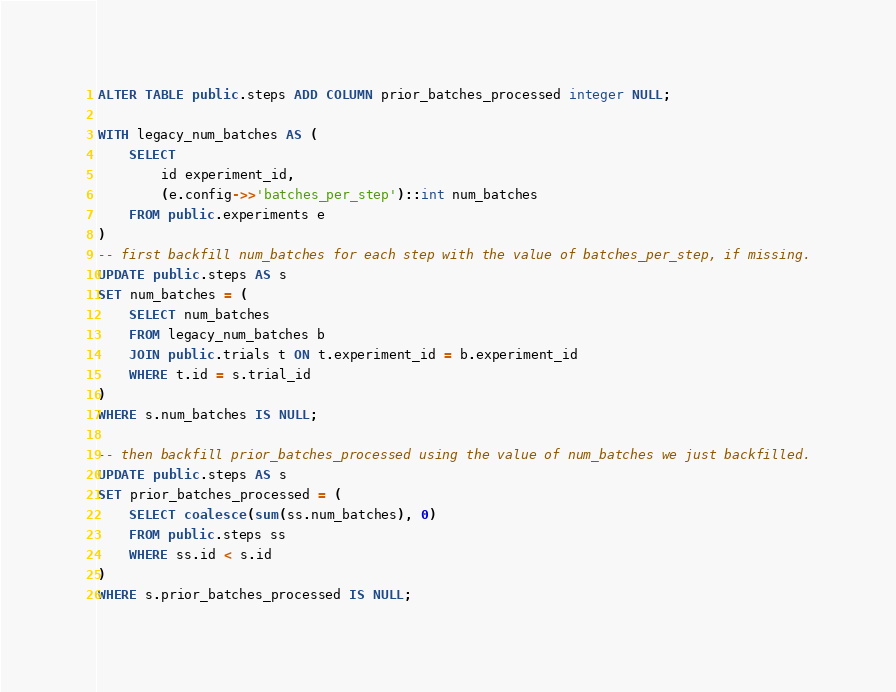Convert code to text. <code><loc_0><loc_0><loc_500><loc_500><_SQL_>ALTER TABLE public.steps ADD COLUMN prior_batches_processed integer NULL;

WITH legacy_num_batches AS (
    SELECT
        id experiment_id,
        (e.config->>'batches_per_step')::int num_batches
    FROM public.experiments e
)
-- first backfill num_batches for each step with the value of batches_per_step, if missing.
UPDATE public.steps AS s
SET num_batches = (
    SELECT num_batches
    FROM legacy_num_batches b
    JOIN public.trials t ON t.experiment_id = b.experiment_id
    WHERE t.id = s.trial_id
)
WHERE s.num_batches IS NULL;

-- then backfill prior_batches_processed using the value of num_batches we just backfilled.
UPDATE public.steps AS s
SET prior_batches_processed = (
    SELECT coalesce(sum(ss.num_batches), 0)
    FROM public.steps ss
    WHERE ss.id < s.id
)
WHERE s.prior_batches_processed IS NULL;
</code> 